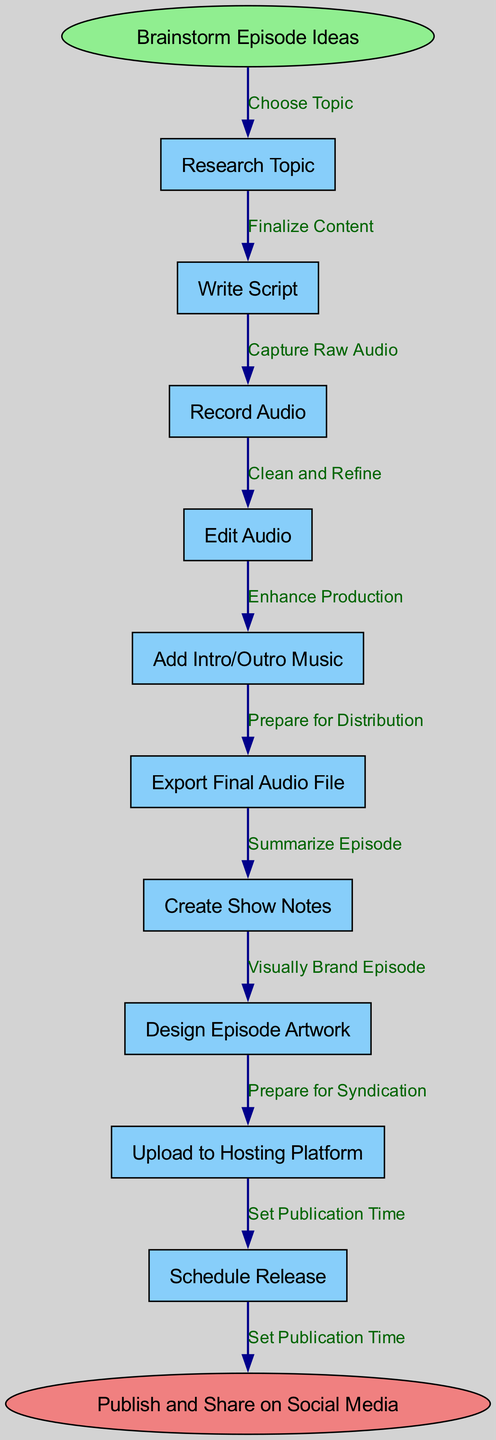What is the start node of the pipeline? The start node is explicitly labeled at the beginning of the pipeline and is indicated as "Brainstorm Episode Ideas."
Answer: Brainstorm Episode Ideas How many nodes are present in the diagram? By counting each distinct functional element listed in the nodes section, there are 10 nodes, including the start and end nodes.
Answer: 10 What is the end node of the pipeline? The end node is clearly defined at the conclusion of the flow and is titled "Publish and Share on Social Media."
Answer: Publish and Share on Social Media What is the first step after "Brainstorm Episode Ideas"? Following the start node, the flow moves directly to "Research Topic," which is the first functional step in the pipeline.
Answer: Research Topic What does the second node in the flow represent? The second node after "Brainstorm Episode Ideas" and "Research Topic" is "Write Script," representing the act of scripting the content for the podcast episode.
Answer: Write Script What is the relationship between “Edit Audio” and “Record Audio”? "Edit Audio" follows "Record Audio" directly, indicating that it occurs after the raw audio has been captured, establishing a sequential dependency in the pipeline.
Answer: Sequential Which node follows "Create Show Notes" in the process? The process flows from "Create Show Notes" to "Design Episode Artwork," indicating the order of completion in the episode creation pipeline.
Answer: Design Episode Artwork How many edges connect the nodes in the diagram? Edges represent the connections between each of the functional steps, and there are 9 edges defined in the diagram, connecting the 10 nodes.
Answer: 9 What step directly precedes the “Upload to Hosting Platform”? The step directly preceding "Upload to Hosting Platform" is "Prepare for Syndication," showcasing the necessary preparations made for publishing.
Answer: Prepare for Syndication What is the last action taken in the podcast episode creation pipeline? The final action, as indicated in the flow, is "Publish and Share on Social Media," serving as the concluding step before the podcast is made publicly available.
Answer: Publish and Share on Social Media 